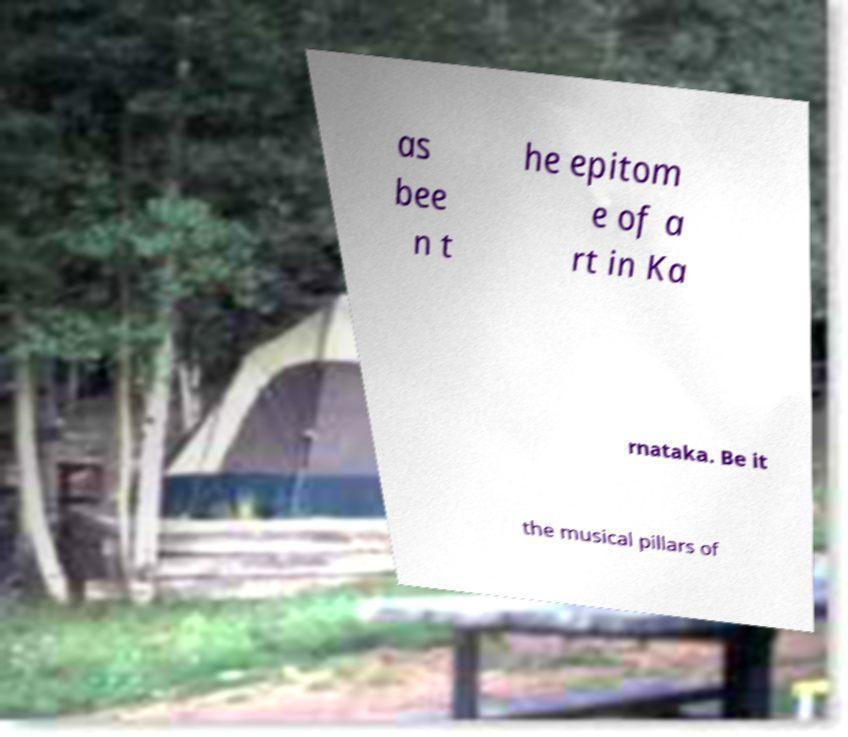Can you accurately transcribe the text from the provided image for me? as bee n t he epitom e of a rt in Ka rnataka. Be it the musical pillars of 